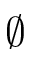<formula> <loc_0><loc_0><loc_500><loc_500>\varnothing</formula> 